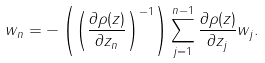<formula> <loc_0><loc_0><loc_500><loc_500>w _ { n } = - \left ( \left ( \frac { \partial \rho ( z ) } { \partial z _ { n } } \right ) ^ { - 1 } \right ) \sum _ { j = 1 } ^ { n - 1 } \frac { \partial \rho ( z ) } { \partial z _ { j } } w _ { j } .</formula> 